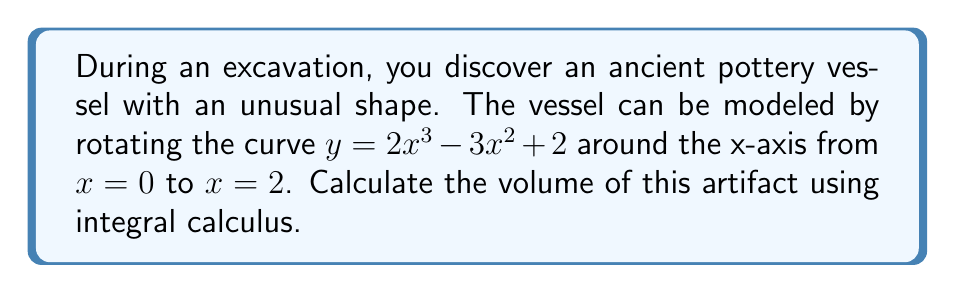Give your solution to this math problem. To calculate the volume of this irregularly shaped artifact, we'll use the method of volumes by rotation (shell method):

1. The volume formula using the shell method is:
   $$V = 2\pi \int_a^b y(x) \cdot x \, dx$$

2. In this case, $y(x) = 2x^3 - 3x^2 + 2$, $a = 0$, and $b = 2$

3. Substituting into the formula:
   $$V = 2\pi \int_0^2 (2x^3 - 3x^2 + 2) \cdot x \, dx$$

4. Distribute $x$ inside the parentheses:
   $$V = 2\pi \int_0^2 (2x^4 - 3x^3 + 2x) \, dx$$

5. Integrate term by term:
   $$V = 2\pi \left[ \frac{2x^5}{5} - \frac{3x^4}{4} + x^2 \right]_0^2$$

6. Evaluate the integral at the limits:
   $$V = 2\pi \left[ \left(\frac{2(2^5)}{5} - \frac{3(2^4)}{4} + 2^2\right) - \left(\frac{2(0^5)}{5} - \frac{3(0^4)}{4} + 0^2\right) \right]$$

7. Simplify:
   $$V = 2\pi \left[ \left(\frac{64}{5} - 12 + 4\right) - 0 \right] = 2\pi \left(\frac{64}{5} - 8\right) = 2\pi \cdot \frac{32}{5} = \frac{64\pi}{5}$$

Therefore, the volume of the artifact is $\frac{64\pi}{5}$ cubic units.
Answer: $\frac{64\pi}{5}$ cubic units 